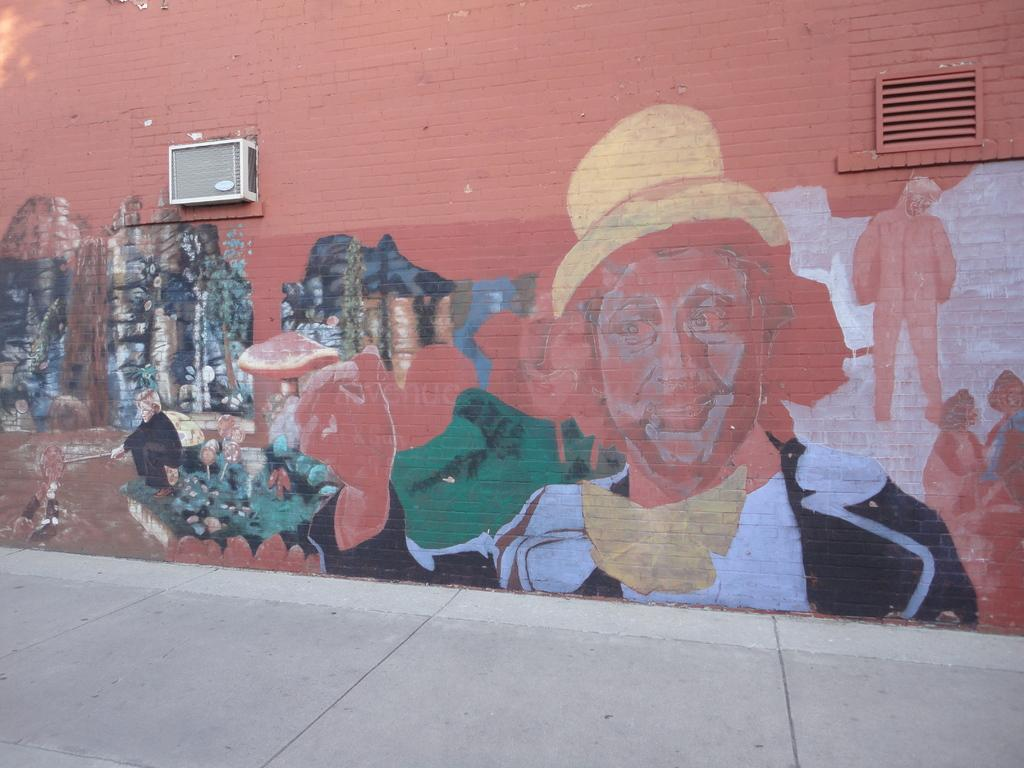What is the main subject of the image? The main subject of the image is a painting on a wall. Where is the painting located in the image? The painting is in the center of the image. Can you identify any other objects in the image? Yes, there appears to be an exhaust fan in the image. What type of loaf is being served in the image? There is no loaf present in the image; it only features a painting on a wall and an exhaust fan. 